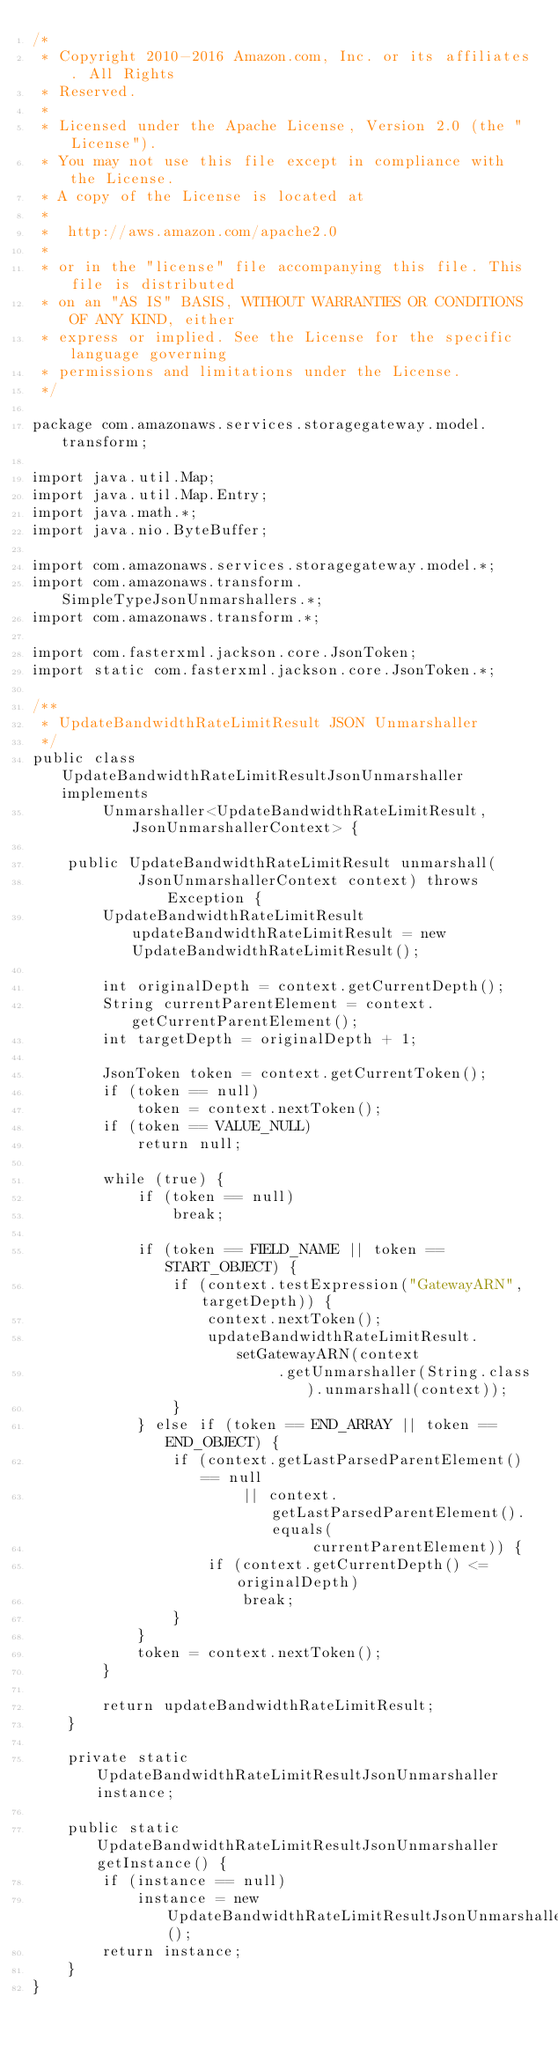<code> <loc_0><loc_0><loc_500><loc_500><_Java_>/*
 * Copyright 2010-2016 Amazon.com, Inc. or its affiliates. All Rights
 * Reserved.
 *
 * Licensed under the Apache License, Version 2.0 (the "License").
 * You may not use this file except in compliance with the License.
 * A copy of the License is located at
 *
 *  http://aws.amazon.com/apache2.0
 *
 * or in the "license" file accompanying this file. This file is distributed
 * on an "AS IS" BASIS, WITHOUT WARRANTIES OR CONDITIONS OF ANY KIND, either
 * express or implied. See the License for the specific language governing
 * permissions and limitations under the License.
 */

package com.amazonaws.services.storagegateway.model.transform;

import java.util.Map;
import java.util.Map.Entry;
import java.math.*;
import java.nio.ByteBuffer;

import com.amazonaws.services.storagegateway.model.*;
import com.amazonaws.transform.SimpleTypeJsonUnmarshallers.*;
import com.amazonaws.transform.*;

import com.fasterxml.jackson.core.JsonToken;
import static com.fasterxml.jackson.core.JsonToken.*;

/**
 * UpdateBandwidthRateLimitResult JSON Unmarshaller
 */
public class UpdateBandwidthRateLimitResultJsonUnmarshaller implements
        Unmarshaller<UpdateBandwidthRateLimitResult, JsonUnmarshallerContext> {

    public UpdateBandwidthRateLimitResult unmarshall(
            JsonUnmarshallerContext context) throws Exception {
        UpdateBandwidthRateLimitResult updateBandwidthRateLimitResult = new UpdateBandwidthRateLimitResult();

        int originalDepth = context.getCurrentDepth();
        String currentParentElement = context.getCurrentParentElement();
        int targetDepth = originalDepth + 1;

        JsonToken token = context.getCurrentToken();
        if (token == null)
            token = context.nextToken();
        if (token == VALUE_NULL)
            return null;

        while (true) {
            if (token == null)
                break;

            if (token == FIELD_NAME || token == START_OBJECT) {
                if (context.testExpression("GatewayARN", targetDepth)) {
                    context.nextToken();
                    updateBandwidthRateLimitResult.setGatewayARN(context
                            .getUnmarshaller(String.class).unmarshall(context));
                }
            } else if (token == END_ARRAY || token == END_OBJECT) {
                if (context.getLastParsedParentElement() == null
                        || context.getLastParsedParentElement().equals(
                                currentParentElement)) {
                    if (context.getCurrentDepth() <= originalDepth)
                        break;
                }
            }
            token = context.nextToken();
        }

        return updateBandwidthRateLimitResult;
    }

    private static UpdateBandwidthRateLimitResultJsonUnmarshaller instance;

    public static UpdateBandwidthRateLimitResultJsonUnmarshaller getInstance() {
        if (instance == null)
            instance = new UpdateBandwidthRateLimitResultJsonUnmarshaller();
        return instance;
    }
}
</code> 